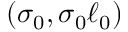<formula> <loc_0><loc_0><loc_500><loc_500>( \sigma _ { 0 } , \sigma _ { 0 } \ell _ { 0 } )</formula> 